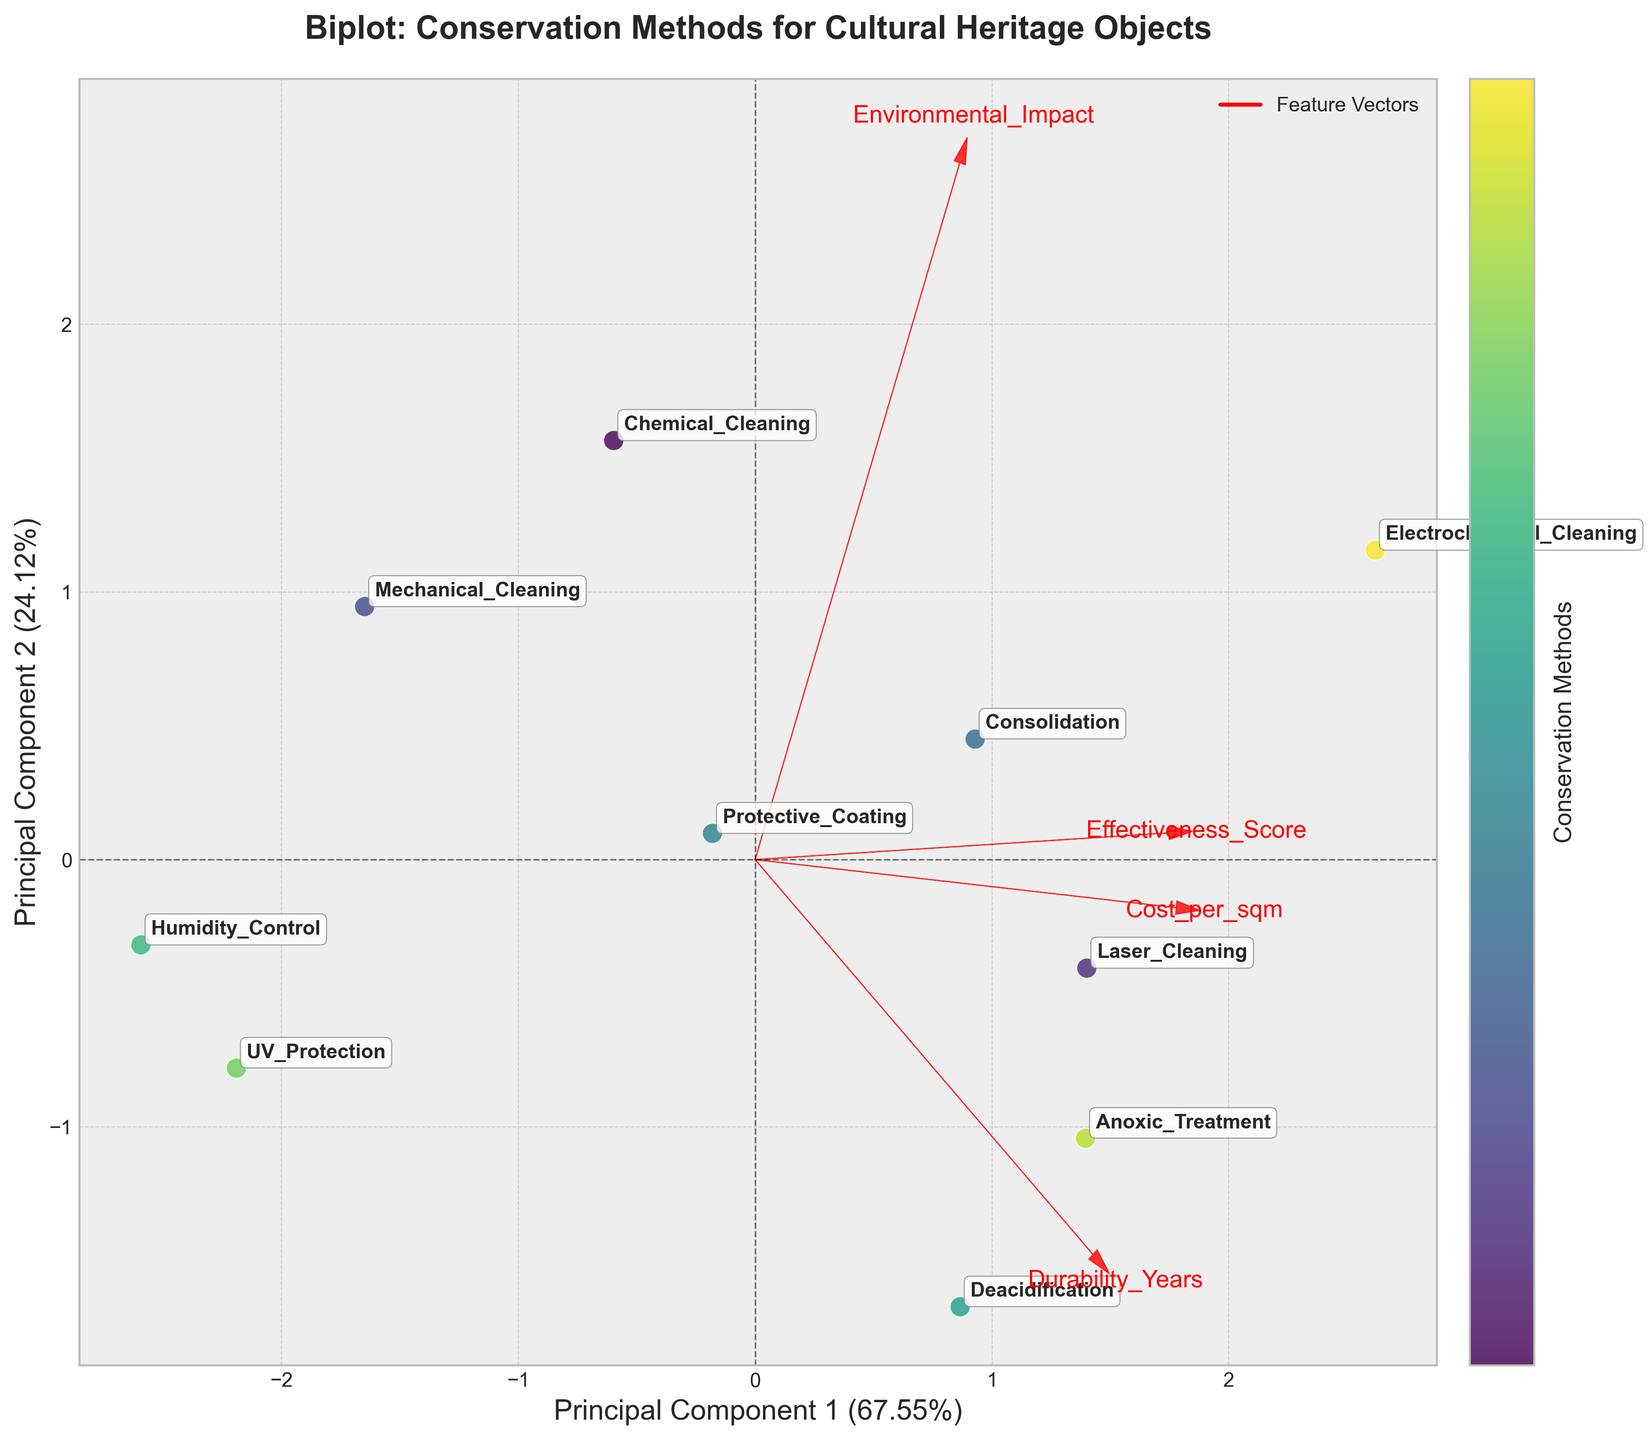How many conservation methods are evaluated in this plot? The plot annotates each data point with a method name; counting these annotations reveals that there are 10 methods.
Answer: 10 What feature has the highest correlation with Principal Component 1? The direction and length of the arrow representing each feature indicate their correlations with the principal components. The feature "Cost_per_sqm" has the longest arrow pointing in the direction of Principal Component 1, signifying the highest correlation.
Answer: Cost_per_sqm Which conservation method has the highest effectiveness score based on the biplot? The annotations and positions of the data points help us identify the methods. The point furthest along the direction of the "Effectiveness_Score" arrow represents the method with the highest score. Here, "Electrochemical_Cleaning" is positioned at the farthest point in that direction.
Answer: Electrochemical_Cleaning Compare the durability of "Deacidification" and "Mechanical_Cleaning" based on the biplot. Which one has a higher value? The features are represented as arrows, and the relative positions of the data points to the arrows indicate their scores. "Deacidification" lies closer to the "Durability_Years" arrow's end, showing a higher value compared to "Mechanical_Cleaning," which is further away.
Answer: Deacidification Which conservation method has the lowest environmental impact according to the biplot? The lowest environmental impact corresponds to the direction with the smallest magnitude on the "Environmental_Impact" arrow. "UV_Protection" is closest to the origin along this direction, indicating it has the lowest environmental impact.
Answer: UV_Protection Based on the biplot, what is the relationship between cost per sqm and environmental impact? Both arrows point in almost the same direction, suggesting a positive correlation between cost per sqm and environmental impact. Higher costs are associated with higher environmental impacts.
Answer: Positive correlation How do the consolidation and anoxic treatment methods compare in terms of effectiveness and cost? The annotations and the directions of arrows for each feature help with this comparison. Consolidation is closer to the "Effectiveness_Score" arrow, indicating high effectiveness but has a lower "Cost_per_sqm" than Anoxic_Treatment, which is further along the "Cost_per_sqm" direction.
Answer: Consolidation is more cost-effective and equally or slightly less effective Which conservation method appears to balance cost and environmental impact most effectively? We look for a method near both the "Cost_per_sqm" and "Environmental_Impact" arrows' origins, indicating low values of both. The "Humidity_Control" method is closest to these origins, suggesting it balances cost and environmental impact well.
Answer: Humidity_Control Is there a conservation method that has both high durability and low cost? By examining the directions of the arrows pertaining to "Durability_Years" and "Cost_per_sqm," we focus on a method pushing high along the durability and near origins for costs. "Protective_Coating" fits these criteria, having relatively low cost and high durability.
Answer: Protective_Coating 